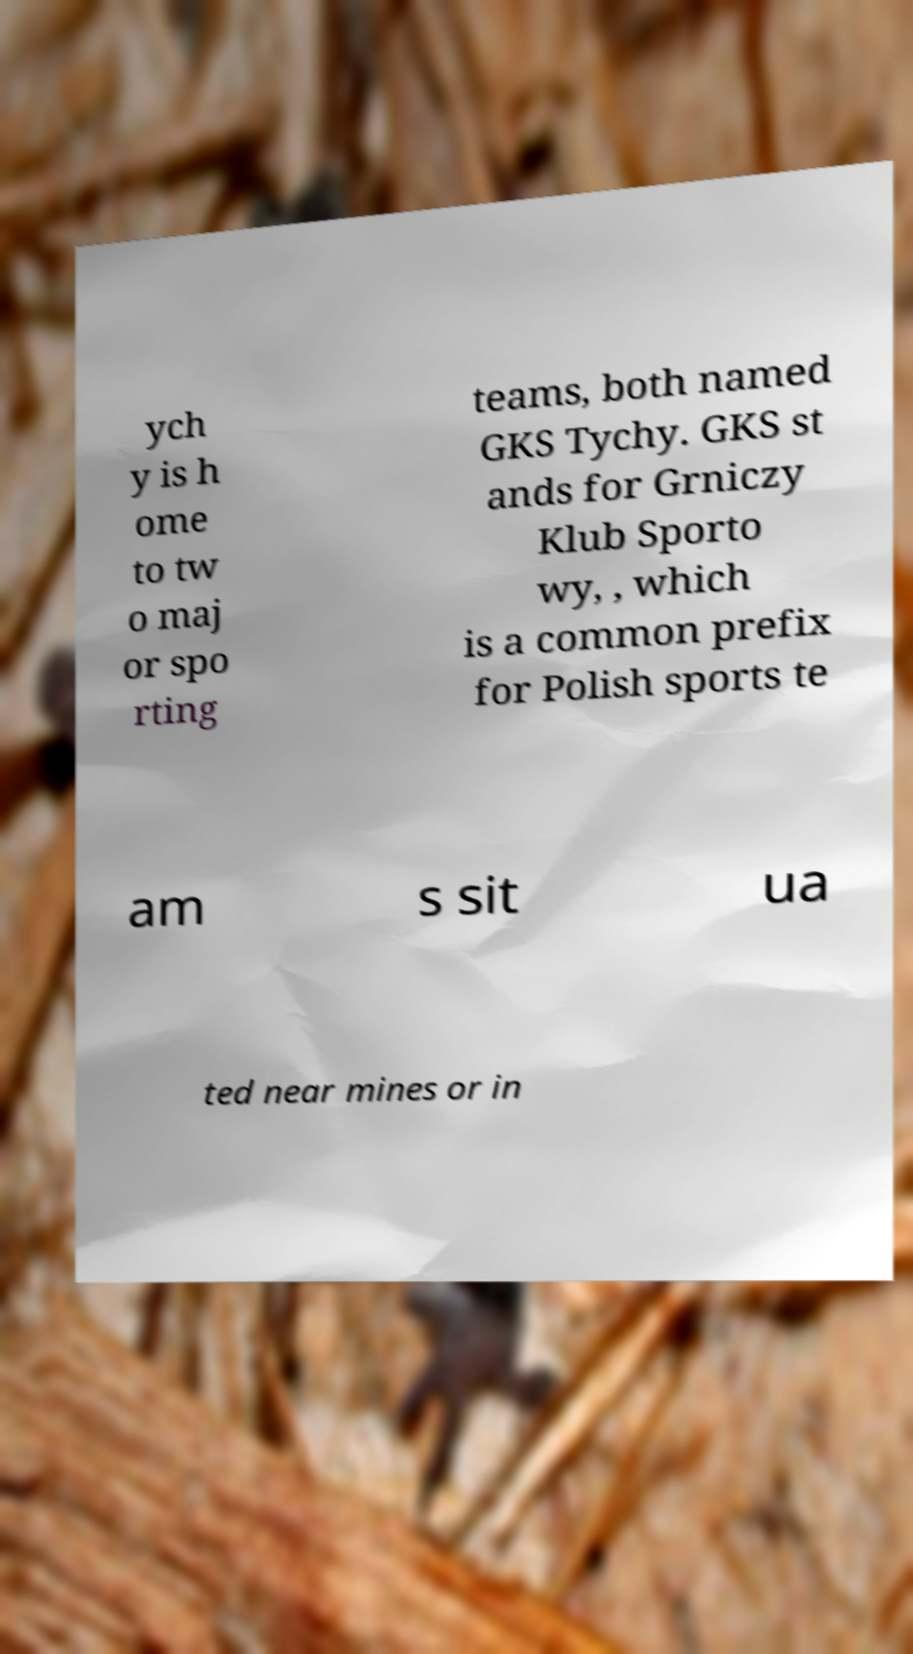Could you extract and type out the text from this image? ych y is h ome to tw o maj or spo rting teams, both named GKS Tychy. GKS st ands for Grniczy Klub Sporto wy, , which is a common prefix for Polish sports te am s sit ua ted near mines or in 